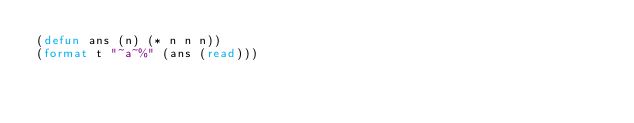<code> <loc_0><loc_0><loc_500><loc_500><_Lisp_>(defun ans (n) (* n n n))
(format t "~a~%" (ans (read)))</code> 